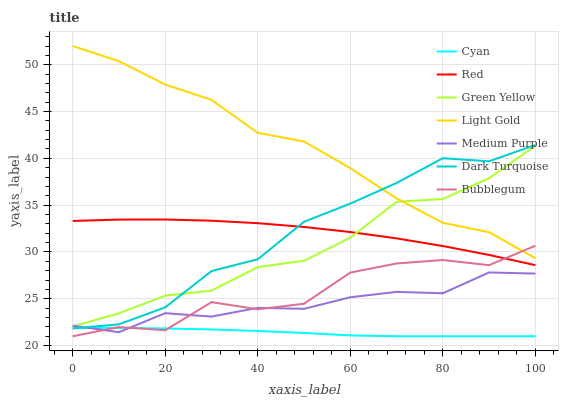Does Bubblegum have the minimum area under the curve?
Answer yes or no. No. Does Bubblegum have the maximum area under the curve?
Answer yes or no. No. Is Medium Purple the smoothest?
Answer yes or no. No. Is Medium Purple the roughest?
Answer yes or no. No. Does Medium Purple have the lowest value?
Answer yes or no. No. Does Bubblegum have the highest value?
Answer yes or no. No. Is Medium Purple less than Red?
Answer yes or no. Yes. Is Dark Turquoise greater than Bubblegum?
Answer yes or no. Yes. Does Medium Purple intersect Red?
Answer yes or no. No. 